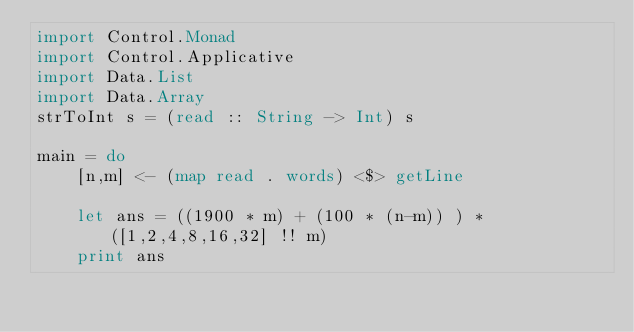<code> <loc_0><loc_0><loc_500><loc_500><_Haskell_>import Control.Monad
import Control.Applicative
import Data.List
import Data.Array
strToInt s = (read :: String -> Int) s

main = do
    [n,m] <- (map read . words) <$> getLine
    
    let ans = ((1900 * m) + (100 * (n-m)) ) * ([1,2,4,8,16,32] !! m)
    print ans</code> 